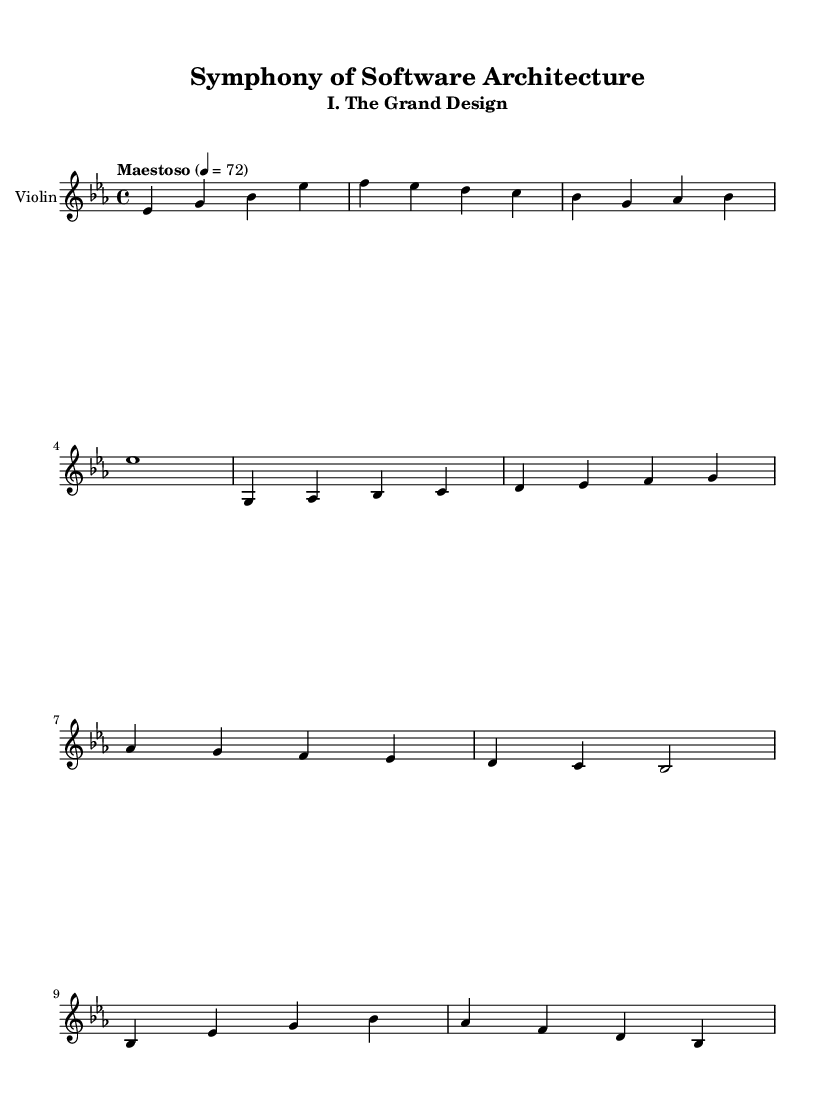What is the key signature of this music? The key signature is E flat major, which has three flats (B flat, E flat, A flat).
Answer: E flat major What is the time signature of this music? The time signature is indicated at the beginning of the score with a '4/4', meaning there are four beats in a measure and the quarter note gets one beat.
Answer: 4/4 What is the tempo marking of this music? The tempo marking is written as "Maestoso", which suggests a majestic and dignified pace, along with a metronome marking of 72 quarter notes per minute.
Answer: Maestoso How many main themes are presented? The score shows two distinct main themes: the main theme and the secondary theme. The music suggests variation but maintains structure around these two ideas.
Answer: Two Identify the clef used in the violin part. The clef used in the violin part is the treble clef, which is standard for violin music, indicating the pitch range suitable for the instrument.
Answer: Treble What type of musical form is primarily suggested by the presence of the main theme, secondary theme, and development motif? The structure resembles a classical sonata form, which includes exposition (introducing themes), development (manipulating themes), and recapitulation (returning to the main themes).
Answer: Sonata form How many measures are there in the main theme? The main theme consists of four measures, each containing four beats, making a total of sixteen beats for the complete phrase.
Answer: Four 